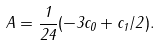<formula> <loc_0><loc_0><loc_500><loc_500>A = \frac { 1 } { 2 4 } ( - 3 c _ { 0 } + c _ { 1 } / 2 ) .</formula> 